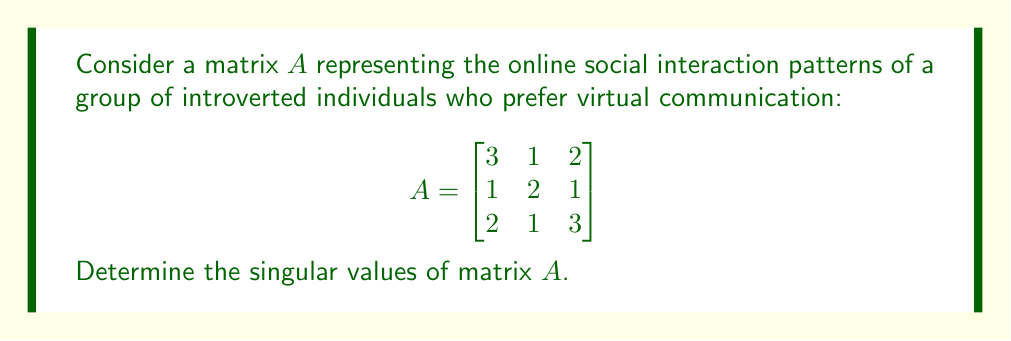Show me your answer to this math problem. To find the singular values of matrix $A$, we follow these steps:

1) First, we need to calculate $A^TA$:

   $$A^TA = \begin{bmatrix}
   3 & 1 & 2 \\
   1 & 2 & 1 \\
   2 & 1 & 3
   \end{bmatrix}
   \begin{bmatrix}
   3 & 1 & 2 \\
   1 & 2 & 1 \\
   2 & 1 & 3
   \end{bmatrix}
   = \begin{bmatrix}
   14 & 7 & 13 \\
   7 & 6 & 7 \\
   13 & 7 & 14
   \end{bmatrix}$$

2) The singular values are the square roots of the eigenvalues of $A^TA$. So, we need to find the eigenvalues by solving the characteristic equation:

   $$\det(A^TA - \lambda I) = 0$$

3) Expanding this determinant:

   $$\begin{vmatrix}
   14-\lambda & 7 & 13 \\
   7 & 6-\lambda & 7 \\
   13 & 7 & 14-\lambda
   \end{vmatrix} = 0$$

4) This expands to:

   $$-\lambda^3 + 34\lambda^2 - 147\lambda + 0 = 0$$

5) Factoring this equation:

   $$-(\lambda - 28)(\lambda - 6)(\lambda - 0) = 0$$

6) So, the eigenvalues of $A^TA$ are 28, 6, and 0.

7) The singular values are the square roots of these eigenvalues:

   $$\sigma_1 = \sqrt{28} = 2\sqrt{7}$$
   $$\sigma_2 = \sqrt{6}$$
   $$\sigma_3 = \sqrt{0} = 0$$

Therefore, the singular values of $A$ are $2\sqrt{7}$, $\sqrt{6}$, and 0.
Answer: $2\sqrt{7}$, $\sqrt{6}$, 0 